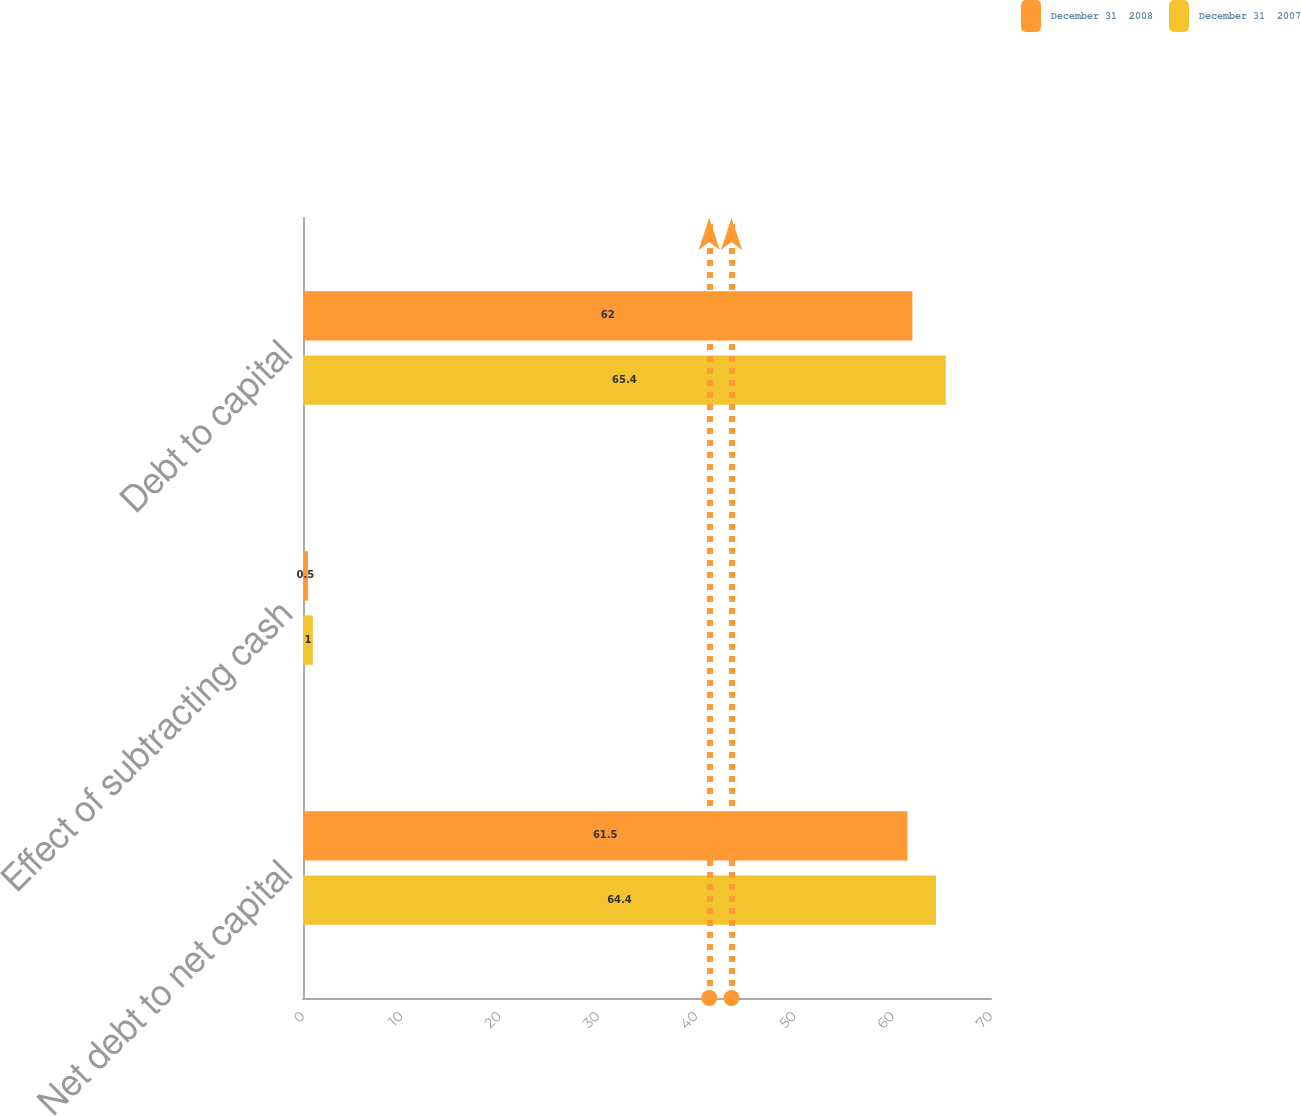<chart> <loc_0><loc_0><loc_500><loc_500><stacked_bar_chart><ecel><fcel>Net debt to net capital<fcel>Effect of subtracting cash<fcel>Debt to capital<nl><fcel>December 31  2008<fcel>61.5<fcel>0.5<fcel>62<nl><fcel>December 31  2007<fcel>64.4<fcel>1<fcel>65.4<nl></chart> 